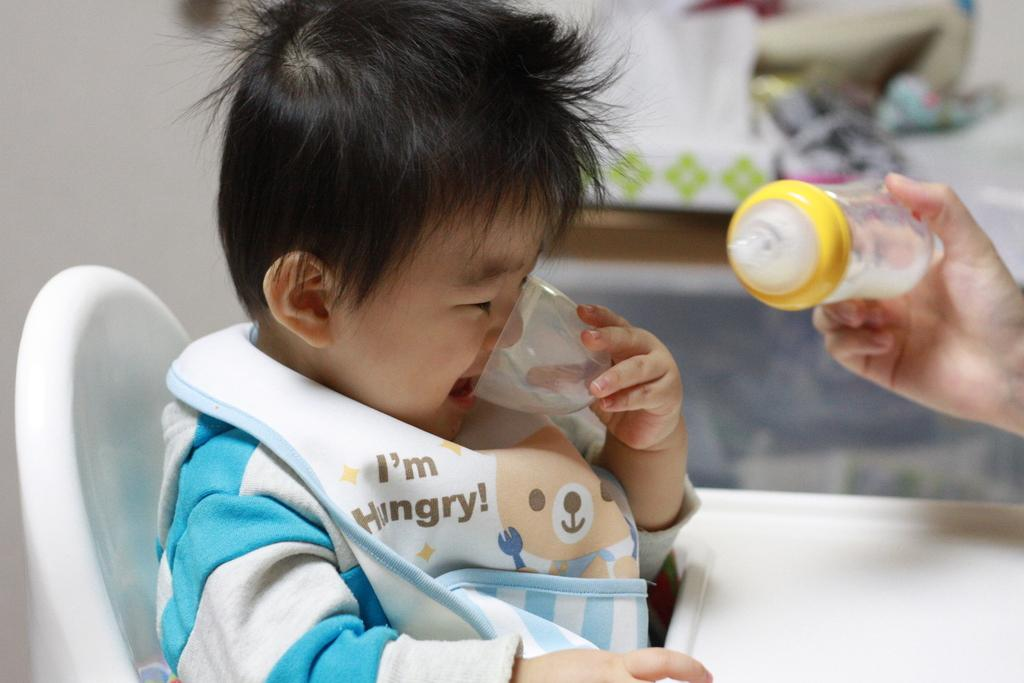<image>
Create a compact narrative representing the image presented. A baby is sitting on a highchair wearing a bib saying I'm hungry! 